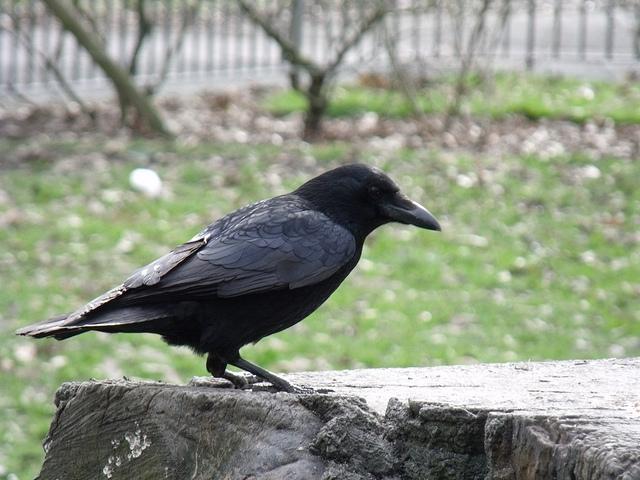What type of bird is shown?
Concise answer only. Crow. What color bird is this?
Be succinct. Black. What color are the bird eyes?
Be succinct. Black. What color is the bird?
Quick response, please. Black. What kind of bird is it?
Concise answer only. Crow. Is it night time?
Keep it brief. No. 